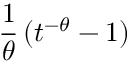<formula> <loc_0><loc_0><loc_500><loc_500>{ \frac { 1 } { \theta } } \, ( t ^ { - \theta } - 1 )</formula> 